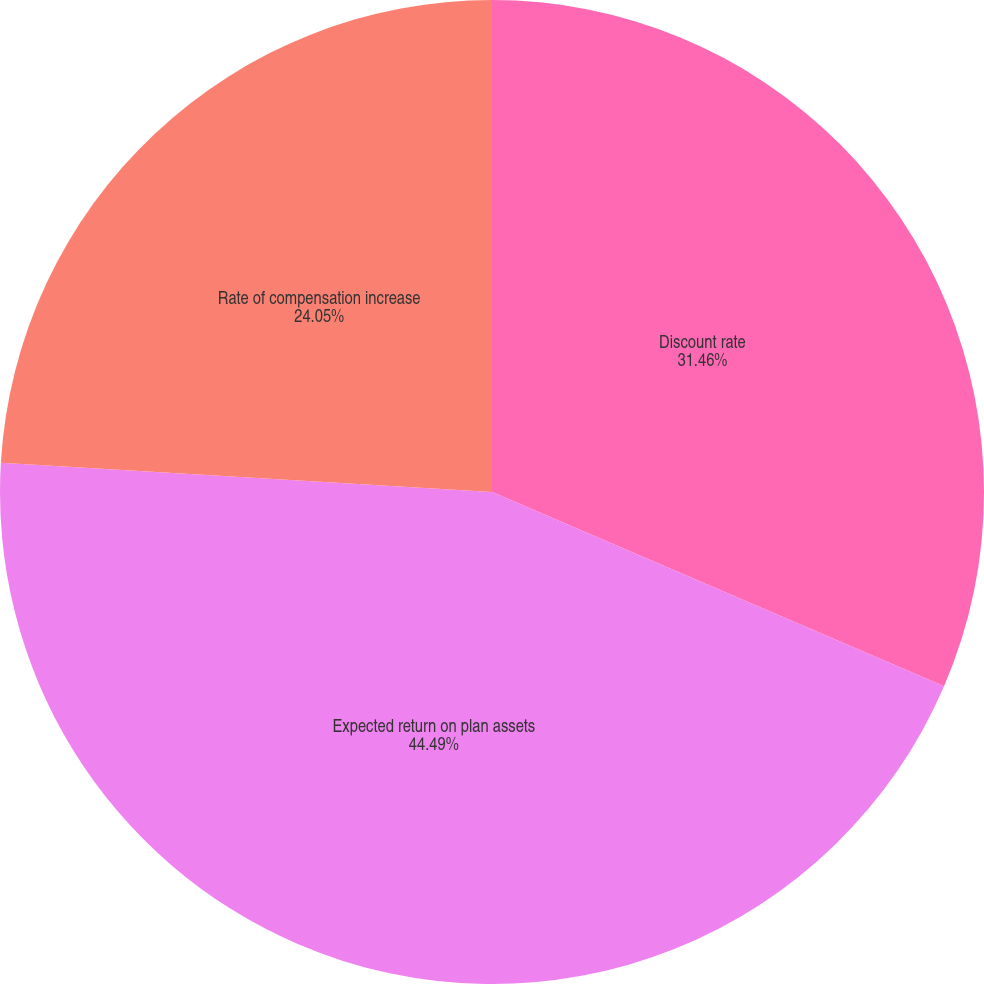Convert chart. <chart><loc_0><loc_0><loc_500><loc_500><pie_chart><fcel>Discount rate<fcel>Expected return on plan assets<fcel>Rate of compensation increase<nl><fcel>31.46%<fcel>44.49%<fcel>24.05%<nl></chart> 